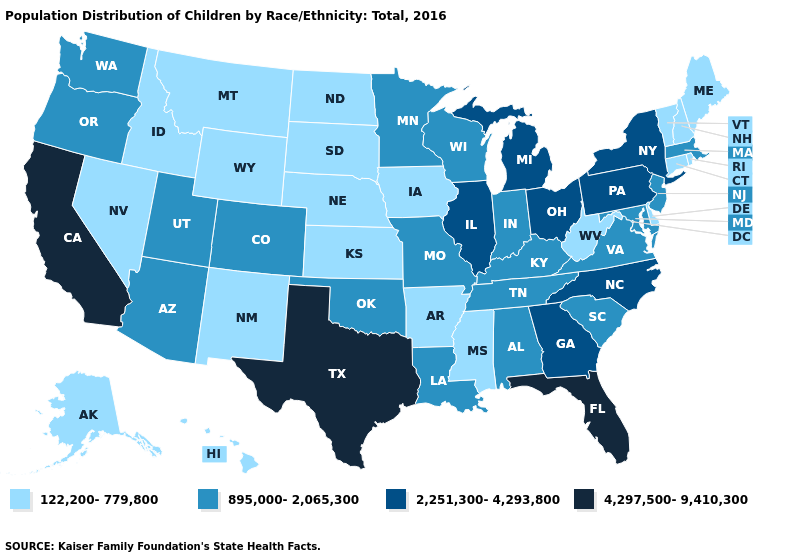Does Nebraska have the lowest value in the MidWest?
Give a very brief answer. Yes. Name the states that have a value in the range 4,297,500-9,410,300?
Give a very brief answer. California, Florida, Texas. Does the map have missing data?
Quick response, please. No. Does Hawaii have the same value as Wyoming?
Short answer required. Yes. Among the states that border Idaho , does Washington have the lowest value?
Give a very brief answer. No. What is the highest value in the MidWest ?
Keep it brief. 2,251,300-4,293,800. What is the value of Maryland?
Keep it brief. 895,000-2,065,300. What is the value of Tennessee?
Be succinct. 895,000-2,065,300. Does California have the highest value in the West?
Quick response, please. Yes. What is the lowest value in the USA?
Answer briefly. 122,200-779,800. Does Mississippi have the lowest value in the USA?
Concise answer only. Yes. What is the highest value in the USA?
Give a very brief answer. 4,297,500-9,410,300. Name the states that have a value in the range 4,297,500-9,410,300?
Short answer required. California, Florida, Texas. Name the states that have a value in the range 2,251,300-4,293,800?
Be succinct. Georgia, Illinois, Michigan, New York, North Carolina, Ohio, Pennsylvania. 